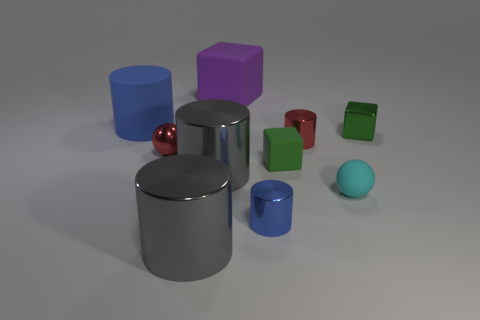Subtract all cyan cylinders. Subtract all green balls. How many cylinders are left? 5 Subtract all balls. How many objects are left? 8 Add 4 small objects. How many small objects exist? 10 Subtract 0 blue cubes. How many objects are left? 10 Subtract all cyan matte objects. Subtract all large green matte spheres. How many objects are left? 9 Add 6 red metal objects. How many red metal objects are left? 8 